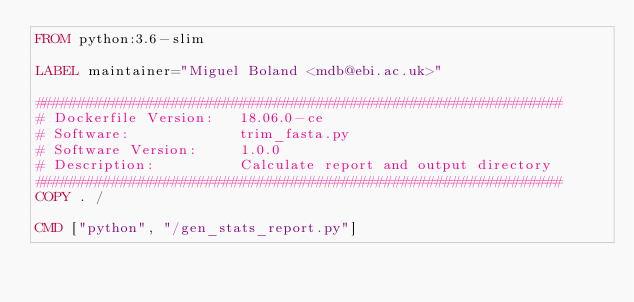Convert code to text. <code><loc_0><loc_0><loc_500><loc_500><_Dockerfile_>FROM python:3.6-slim

LABEL maintainer="Miguel Boland <mdb@ebi.ac.uk>"

##############################################################
# Dockerfile Version:   18.06.0-ce
# Software:             trim_fasta.py
# Software Version:     1.0.0
# Description:          Calculate report and output directory
##############################################################
COPY . /

CMD ["python", "/gen_stats_report.py"]

</code> 